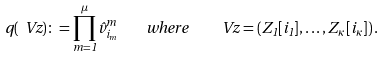Convert formula to latex. <formula><loc_0><loc_0><loc_500><loc_500>q ( \ V { z } ) \colon = \prod _ { m = 1 } ^ { \mu } \hat { v } ^ { m } _ { i _ { m } } \quad w h e r e \quad \ V { z } = \left ( Z _ { 1 } [ i _ { 1 } ] , \dots , Z _ { \kappa } [ i _ { \kappa } ] \right ) .</formula> 